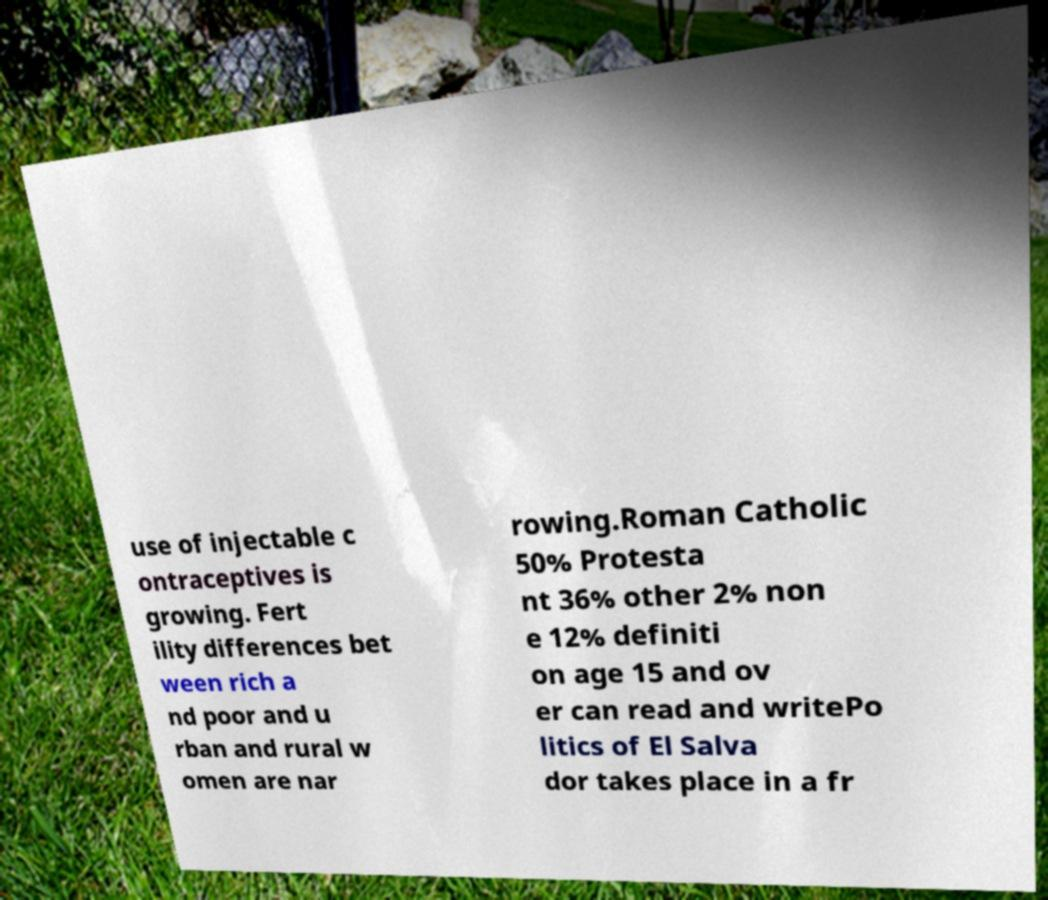Can you read and provide the text displayed in the image?This photo seems to have some interesting text. Can you extract and type it out for me? use of injectable c ontraceptives is growing. Fert ility differences bet ween rich a nd poor and u rban and rural w omen are nar rowing.Roman Catholic 50% Protesta nt 36% other 2% non e 12% definiti on age 15 and ov er can read and writePo litics of El Salva dor takes place in a fr 